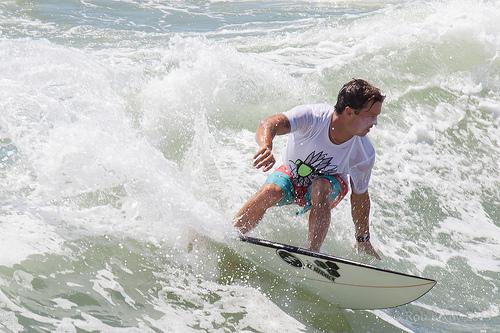Question: what is the man riding on?
Choices:
A. A surfboard.
B. A motorcycle.
C. A horse.
D. A skateboard.
Answer with the letter. Answer: A Question: what colors are the surfboard?
Choices:
A. Orange and blue.
B. Red and yellow.
C. White and black.
D. Lime green and yellow.
Answer with the letter. Answer: C Question: who is on the surfboard?
Choices:
A. A man in blue trunks.
B. A blonde woman.
C. A surfer.
D. A teenage girl.
Answer with the letter. Answer: C Question: where is the surfer surfing?
Choices:
A. In the sea.
B. In Hawaii.
C. In the ocean.
D. In Australia.
Answer with the letter. Answer: C Question: why is the man on the board?
Choices:
A. The man is skateboarding.
B. The man is snowboating.
C. The man is surfing.
D. The man is trying to stay afloat.
Answer with the letter. Answer: C Question: what is the man doing?
Choices:
A. Jogging.
B. Surfing.
C. Running.
D. Walking.
Answer with the letter. Answer: B 